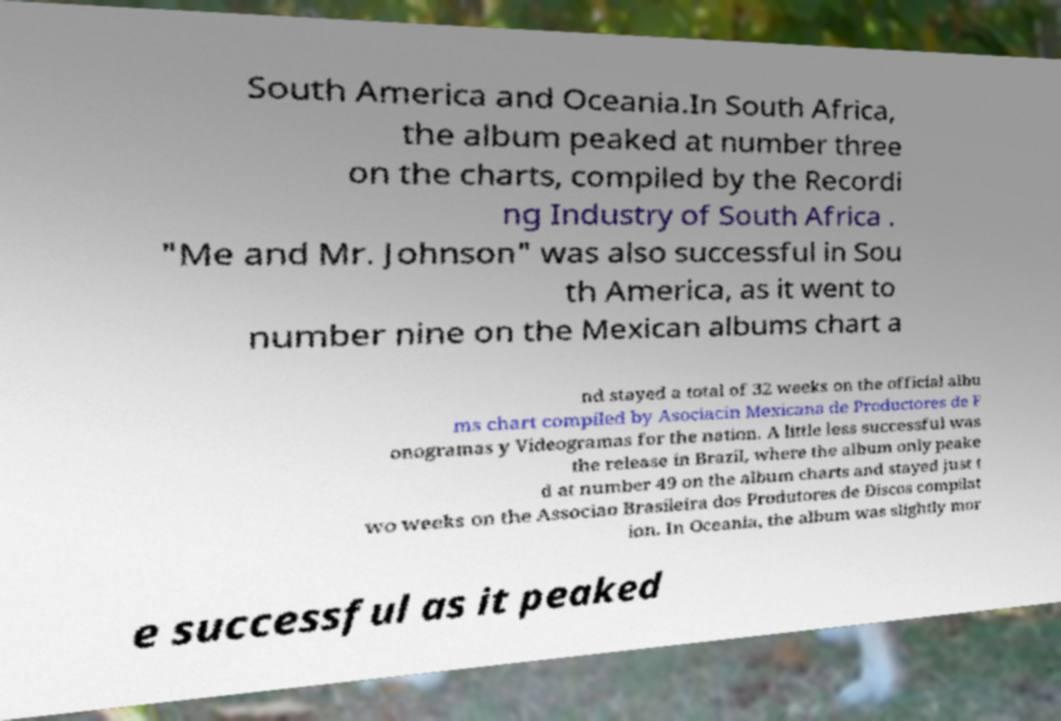Could you extract and type out the text from this image? South America and Oceania.In South Africa, the album peaked at number three on the charts, compiled by the Recordi ng Industry of South Africa . "Me and Mr. Johnson" was also successful in Sou th America, as it went to number nine on the Mexican albums chart a nd stayed a total of 32 weeks on the official albu ms chart compiled by Asociacin Mexicana de Productores de F onogramas y Videogramas for the nation. A little less successful was the release in Brazil, where the album only peake d at number 49 on the album charts and stayed just t wo weeks on the Associao Brasileira dos Produtores de Discos compilat ion. In Oceania, the album was slightly mor e successful as it peaked 